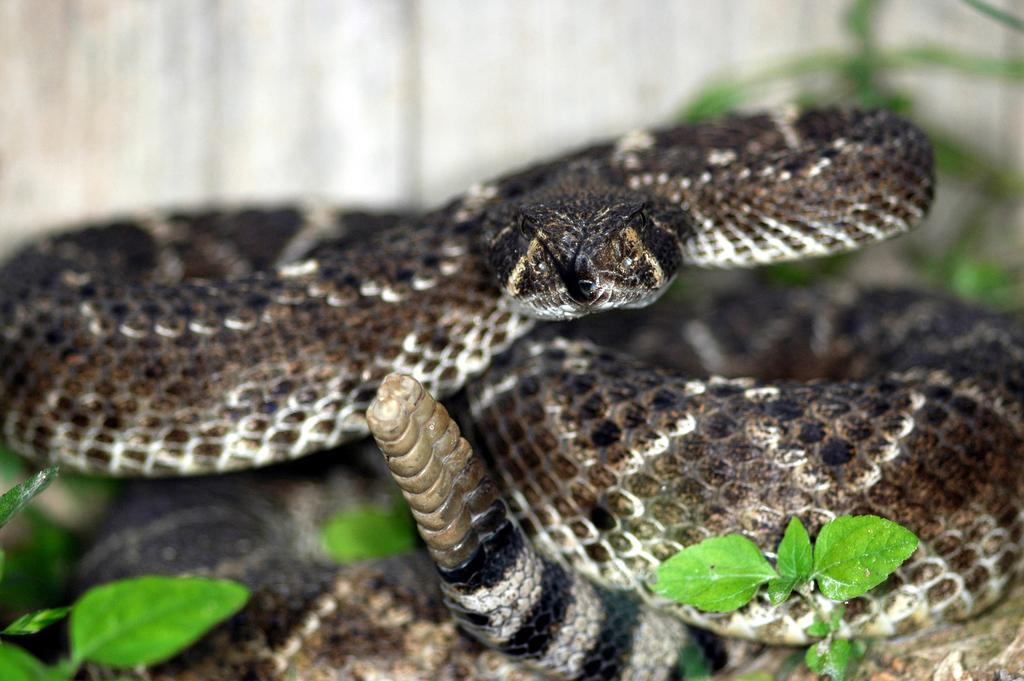What animal is present in the image? There is a snake in the image. What type of vegetation can be seen at the bottom of the image? Leaves are visible at the bottom of the image. How would you describe the background of the image? The background of the image is blurred. What type of apparatus is being used to push the snake in the image? There is no apparatus or pushing action present in the image; the snake is stationary. 